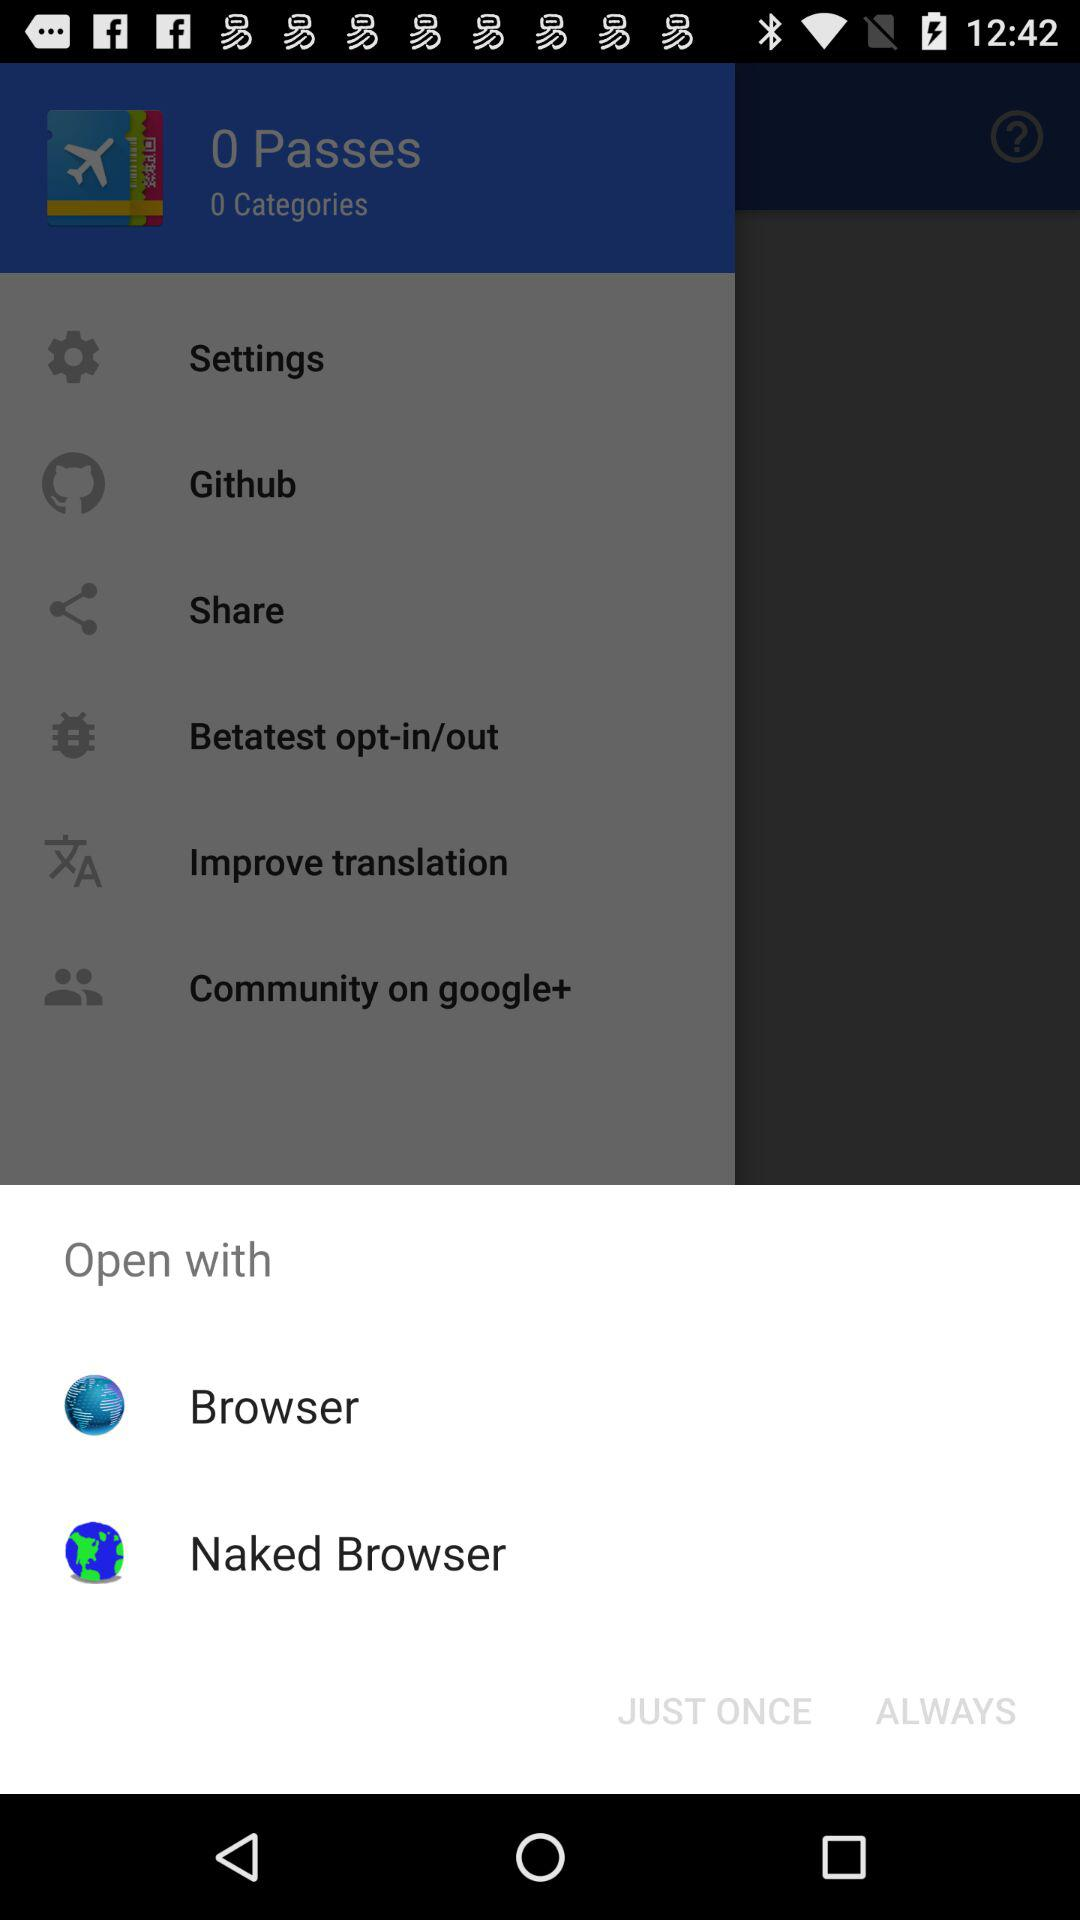What are the options to open with? The options to open with are "Browser" and "Naked Browser". 